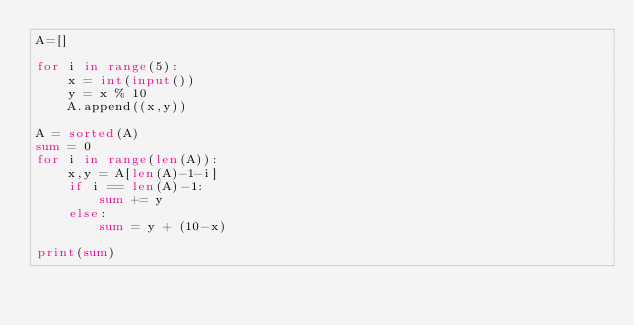Convert code to text. <code><loc_0><loc_0><loc_500><loc_500><_Python_>A=[]

for i in range(5):
    x = int(input())
    y = x % 10
    A.append((x,y))

A = sorted(A)
sum = 0
for i in range(len(A)):
    x,y = A[len(A)-1-i]
    if i == len(A)-1:
        sum += y
    else:
        sum = y + (10-x)

print(sum)
</code> 